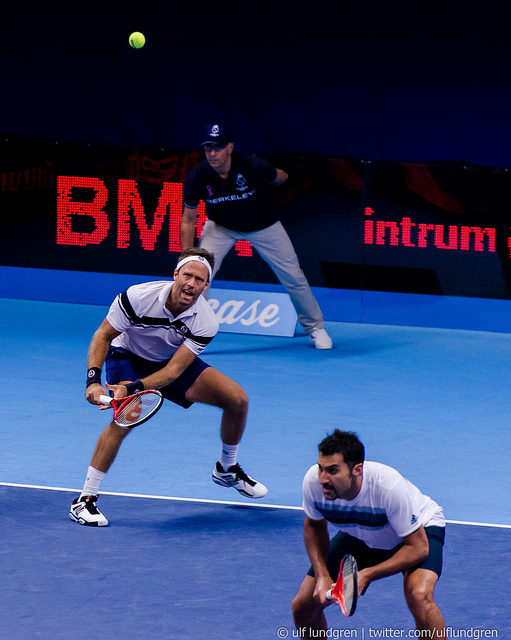<image>What car manufacturer sponsors this sport? I am not sure. Although it is mostly 'bmw', there might be no car manufacturer sponsoring this sport. What car manufacturer sponsors this sport? The car manufacturer that sponsors this sport is BMW. 